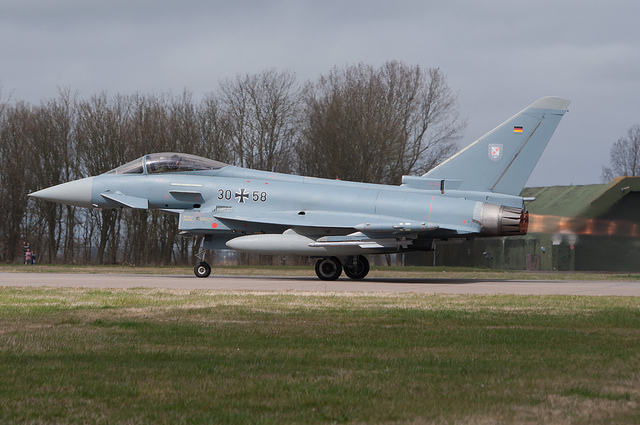Extract all visible text content from this image. 30 58 